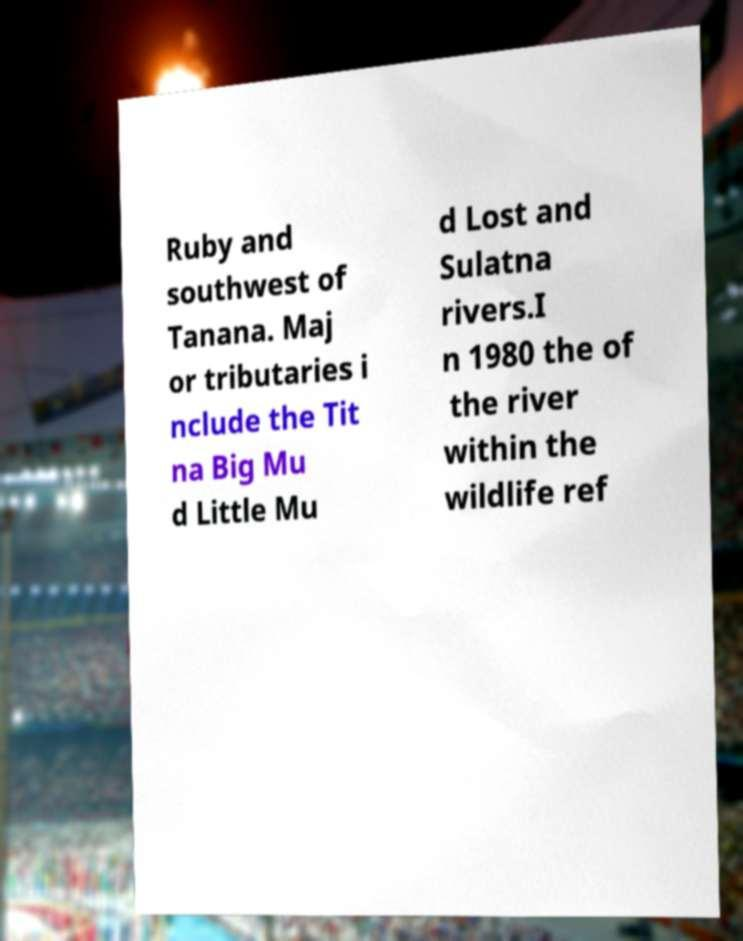For documentation purposes, I need the text within this image transcribed. Could you provide that? Ruby and southwest of Tanana. Maj or tributaries i nclude the Tit na Big Mu d Little Mu d Lost and Sulatna rivers.I n 1980 the of the river within the wildlife ref 